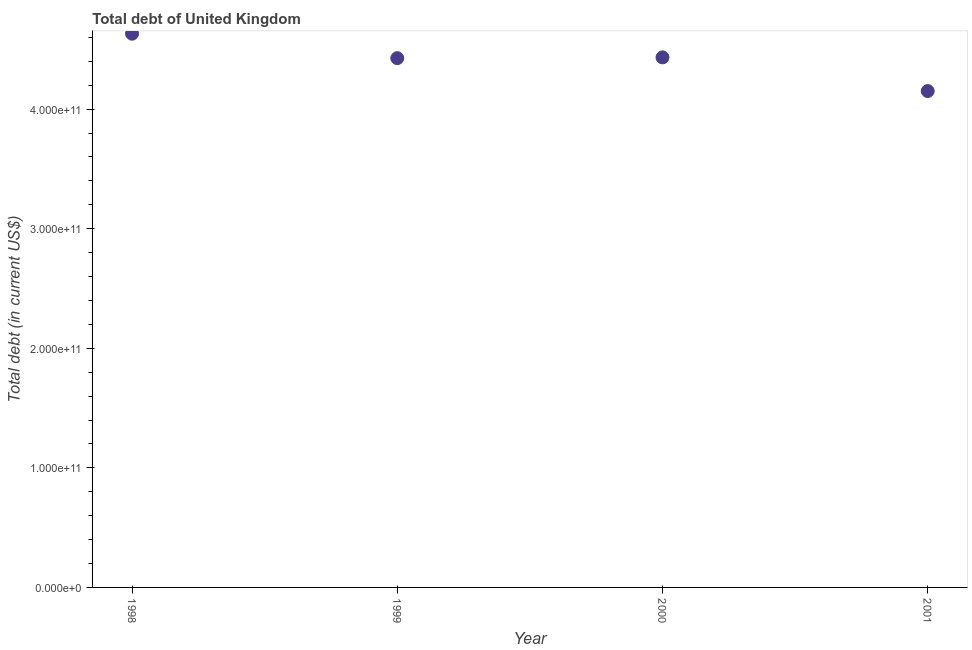What is the total debt in 1998?
Offer a very short reply. 4.63e+11. Across all years, what is the maximum total debt?
Offer a terse response. 4.63e+11. Across all years, what is the minimum total debt?
Offer a terse response. 4.15e+11. In which year was the total debt maximum?
Provide a short and direct response. 1998. In which year was the total debt minimum?
Make the answer very short. 2001. What is the sum of the total debt?
Offer a very short reply. 1.76e+12. What is the difference between the total debt in 1998 and 1999?
Your answer should be very brief. 2.05e+1. What is the average total debt per year?
Provide a succinct answer. 4.41e+11. What is the median total debt?
Make the answer very short. 4.43e+11. In how many years, is the total debt greater than 200000000000 US$?
Ensure brevity in your answer.  4. What is the ratio of the total debt in 2000 to that in 2001?
Make the answer very short. 1.07. Is the total debt in 1998 less than that in 2000?
Provide a succinct answer. No. Is the difference between the total debt in 1998 and 2001 greater than the difference between any two years?
Keep it short and to the point. Yes. What is the difference between the highest and the second highest total debt?
Provide a succinct answer. 1.98e+1. What is the difference between the highest and the lowest total debt?
Ensure brevity in your answer.  4.80e+1. In how many years, is the total debt greater than the average total debt taken over all years?
Offer a terse response. 3. How many years are there in the graph?
Offer a terse response. 4. What is the difference between two consecutive major ticks on the Y-axis?
Offer a very short reply. 1.00e+11. Are the values on the major ticks of Y-axis written in scientific E-notation?
Keep it short and to the point. Yes. What is the title of the graph?
Ensure brevity in your answer.  Total debt of United Kingdom. What is the label or title of the X-axis?
Keep it short and to the point. Year. What is the label or title of the Y-axis?
Provide a succinct answer. Total debt (in current US$). What is the Total debt (in current US$) in 1998?
Offer a very short reply. 4.63e+11. What is the Total debt (in current US$) in 1999?
Offer a terse response. 4.43e+11. What is the Total debt (in current US$) in 2000?
Ensure brevity in your answer.  4.43e+11. What is the Total debt (in current US$) in 2001?
Provide a succinct answer. 4.15e+11. What is the difference between the Total debt (in current US$) in 1998 and 1999?
Your response must be concise. 2.05e+1. What is the difference between the Total debt (in current US$) in 1998 and 2000?
Your answer should be very brief. 1.98e+1. What is the difference between the Total debt (in current US$) in 1998 and 2001?
Offer a very short reply. 4.80e+1. What is the difference between the Total debt (in current US$) in 1999 and 2000?
Provide a succinct answer. -6.65e+08. What is the difference between the Total debt (in current US$) in 1999 and 2001?
Your response must be concise. 2.75e+1. What is the difference between the Total debt (in current US$) in 2000 and 2001?
Make the answer very short. 2.82e+1. What is the ratio of the Total debt (in current US$) in 1998 to that in 1999?
Ensure brevity in your answer.  1.05. What is the ratio of the Total debt (in current US$) in 1998 to that in 2000?
Give a very brief answer. 1.04. What is the ratio of the Total debt (in current US$) in 1998 to that in 2001?
Offer a terse response. 1.12. What is the ratio of the Total debt (in current US$) in 1999 to that in 2000?
Your response must be concise. 1. What is the ratio of the Total debt (in current US$) in 1999 to that in 2001?
Offer a very short reply. 1.07. What is the ratio of the Total debt (in current US$) in 2000 to that in 2001?
Offer a terse response. 1.07. 